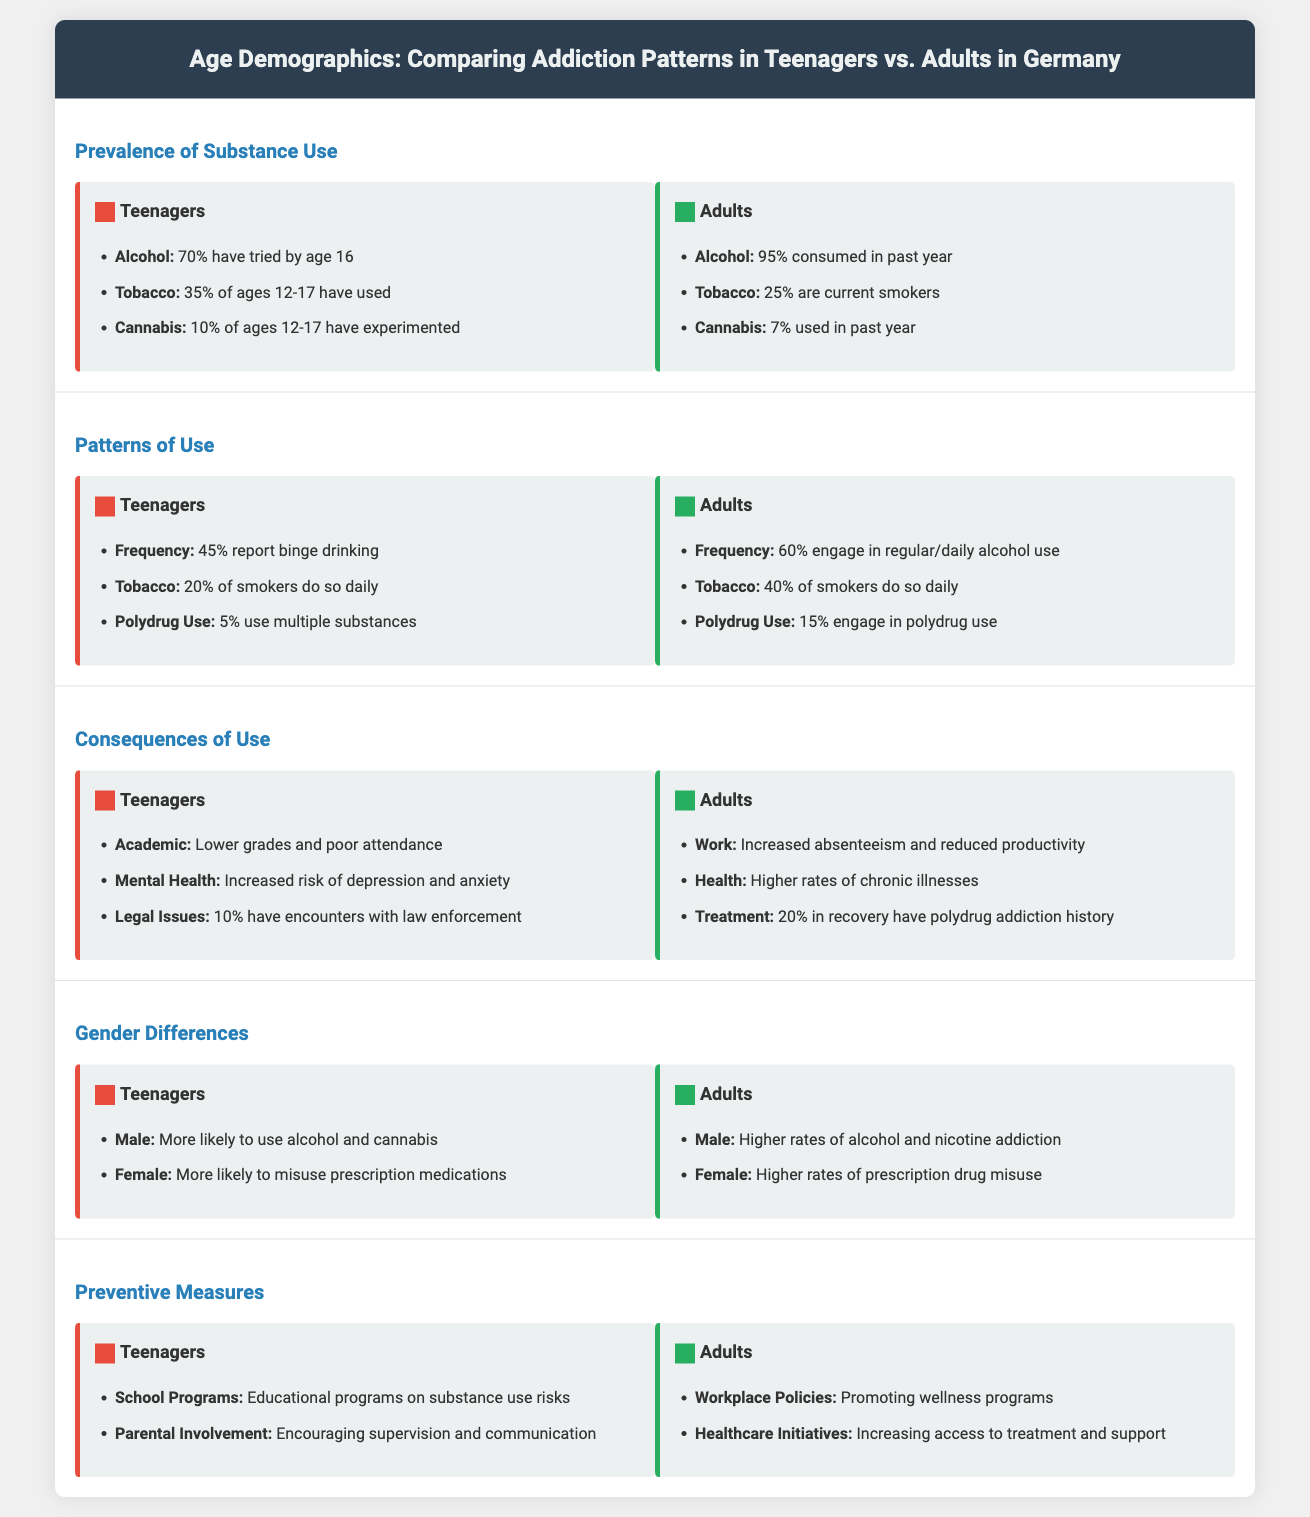What percentage of teenagers have tried alcohol by age 16? The document states that 70% of teenagers have tried alcohol by age 16.
Answer: 70% What is the polydrug use percentage among adults? The document indicates that 15% of adults engage in polydrug use.
Answer: 15% Which substance has a higher prevalence of use among teenagers compared to adults? The comparison shows 35% of teenagers have used tobacco versus 25% of adults.
Answer: Tobacco What percentage of teenagers report binge drinking? The document provides that 45% of teenagers report binge drinking.
Answer: 45% Which gender among teenagers is more likely to misuse prescription medications? The infographic mentions that females are more likely to misuse prescription medications among teenagers.
Answer: Female What are the main consequences of substance use for teenagers? The document lists lower grades, increased risk of depression, and 10% encountering law enforcement.
Answer: Lower grades and poor attendance What preventive measure is recommended for adults? The document suggests promoting workplace policies for wellness programs.
Answer: Workplace Policies Which substance shows a higher usage percentage in adults compared to teenagers? The adult category shows 95% consumed alcohol in the past year compared to teenagers.
Answer: Alcohol What is the frequency of regular/daily alcohol use among adults? The infographic states that 60% of adults engage in regular/daily alcohol use.
Answer: 60% 